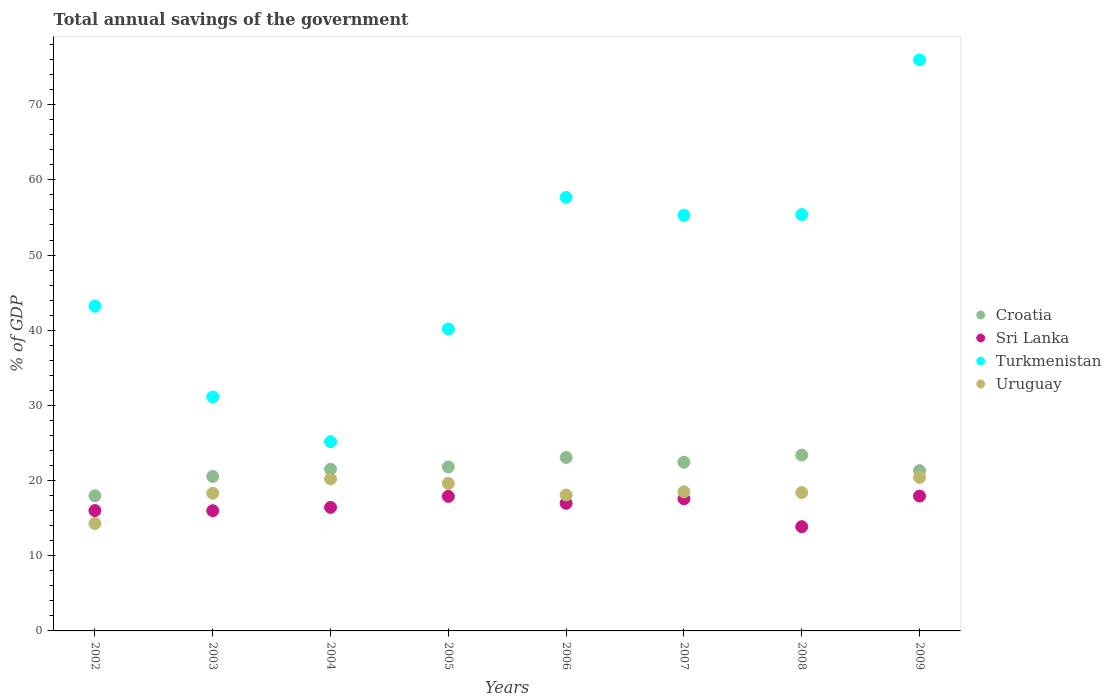How many different coloured dotlines are there?
Your answer should be compact. 4. Is the number of dotlines equal to the number of legend labels?
Offer a very short reply. Yes. What is the total annual savings of the government in Sri Lanka in 2002?
Make the answer very short. 16.01. Across all years, what is the maximum total annual savings of the government in Sri Lanka?
Provide a succinct answer. 17.94. Across all years, what is the minimum total annual savings of the government in Croatia?
Your response must be concise. 17.98. In which year was the total annual savings of the government in Uruguay maximum?
Provide a succinct answer. 2009. In which year was the total annual savings of the government in Turkmenistan minimum?
Offer a terse response. 2004. What is the total total annual savings of the government in Turkmenistan in the graph?
Provide a succinct answer. 383.96. What is the difference between the total annual savings of the government in Sri Lanka in 2005 and that in 2008?
Provide a short and direct response. 4.03. What is the difference between the total annual savings of the government in Turkmenistan in 2006 and the total annual savings of the government in Sri Lanka in 2003?
Make the answer very short. 41.68. What is the average total annual savings of the government in Croatia per year?
Give a very brief answer. 21.51. In the year 2008, what is the difference between the total annual savings of the government in Croatia and total annual savings of the government in Uruguay?
Keep it short and to the point. 4.99. What is the ratio of the total annual savings of the government in Uruguay in 2006 to that in 2009?
Ensure brevity in your answer.  0.89. Is the total annual savings of the government in Croatia in 2007 less than that in 2009?
Your answer should be very brief. No. What is the difference between the highest and the second highest total annual savings of the government in Croatia?
Offer a very short reply. 0.33. What is the difference between the highest and the lowest total annual savings of the government in Sri Lanka?
Provide a succinct answer. 4.08. Is it the case that in every year, the sum of the total annual savings of the government in Turkmenistan and total annual savings of the government in Croatia  is greater than the total annual savings of the government in Sri Lanka?
Offer a terse response. Yes. Does the total annual savings of the government in Turkmenistan monotonically increase over the years?
Give a very brief answer. No. Is the total annual savings of the government in Sri Lanka strictly greater than the total annual savings of the government in Uruguay over the years?
Offer a terse response. No. How many dotlines are there?
Provide a succinct answer. 4. How many years are there in the graph?
Give a very brief answer. 8. What is the difference between two consecutive major ticks on the Y-axis?
Make the answer very short. 10. How many legend labels are there?
Your answer should be very brief. 4. How are the legend labels stacked?
Offer a very short reply. Vertical. What is the title of the graph?
Provide a succinct answer. Total annual savings of the government. What is the label or title of the X-axis?
Make the answer very short. Years. What is the label or title of the Y-axis?
Provide a succinct answer. % of GDP. What is the % of GDP of Croatia in 2002?
Make the answer very short. 17.98. What is the % of GDP in Sri Lanka in 2002?
Offer a very short reply. 16.01. What is the % of GDP of Turkmenistan in 2002?
Your answer should be compact. 43.2. What is the % of GDP in Uruguay in 2002?
Your response must be concise. 14.29. What is the % of GDP of Croatia in 2003?
Provide a short and direct response. 20.55. What is the % of GDP in Sri Lanka in 2003?
Your answer should be compact. 15.99. What is the % of GDP in Turkmenistan in 2003?
Your answer should be compact. 31.12. What is the % of GDP in Uruguay in 2003?
Keep it short and to the point. 18.31. What is the % of GDP of Croatia in 2004?
Your answer should be compact. 21.52. What is the % of GDP of Sri Lanka in 2004?
Your answer should be very brief. 16.43. What is the % of GDP of Turkmenistan in 2004?
Offer a terse response. 25.17. What is the % of GDP of Uruguay in 2004?
Your answer should be very brief. 20.22. What is the % of GDP in Croatia in 2005?
Keep it short and to the point. 21.8. What is the % of GDP of Sri Lanka in 2005?
Your response must be concise. 17.9. What is the % of GDP of Turkmenistan in 2005?
Offer a very short reply. 40.17. What is the % of GDP of Uruguay in 2005?
Provide a short and direct response. 19.63. What is the % of GDP of Croatia in 2006?
Provide a short and direct response. 23.07. What is the % of GDP in Sri Lanka in 2006?
Provide a succinct answer. 16.98. What is the % of GDP of Turkmenistan in 2006?
Your answer should be compact. 57.67. What is the % of GDP in Uruguay in 2006?
Provide a short and direct response. 18.08. What is the % of GDP in Croatia in 2007?
Provide a succinct answer. 22.44. What is the % of GDP of Sri Lanka in 2007?
Give a very brief answer. 17.58. What is the % of GDP of Turkmenistan in 2007?
Give a very brief answer. 55.29. What is the % of GDP of Uruguay in 2007?
Make the answer very short. 18.5. What is the % of GDP in Croatia in 2008?
Your response must be concise. 23.39. What is the % of GDP in Sri Lanka in 2008?
Provide a short and direct response. 13.87. What is the % of GDP in Turkmenistan in 2008?
Provide a succinct answer. 55.38. What is the % of GDP in Uruguay in 2008?
Keep it short and to the point. 18.41. What is the % of GDP of Croatia in 2009?
Your answer should be very brief. 21.32. What is the % of GDP in Sri Lanka in 2009?
Your answer should be compact. 17.94. What is the % of GDP of Turkmenistan in 2009?
Your response must be concise. 75.96. What is the % of GDP of Uruguay in 2009?
Your response must be concise. 20.42. Across all years, what is the maximum % of GDP of Croatia?
Offer a terse response. 23.39. Across all years, what is the maximum % of GDP in Sri Lanka?
Your answer should be compact. 17.94. Across all years, what is the maximum % of GDP in Turkmenistan?
Keep it short and to the point. 75.96. Across all years, what is the maximum % of GDP of Uruguay?
Provide a succinct answer. 20.42. Across all years, what is the minimum % of GDP of Croatia?
Offer a terse response. 17.98. Across all years, what is the minimum % of GDP in Sri Lanka?
Offer a very short reply. 13.87. Across all years, what is the minimum % of GDP in Turkmenistan?
Your answer should be compact. 25.17. Across all years, what is the minimum % of GDP of Uruguay?
Your answer should be very brief. 14.29. What is the total % of GDP of Croatia in the graph?
Keep it short and to the point. 172.07. What is the total % of GDP of Sri Lanka in the graph?
Make the answer very short. 132.69. What is the total % of GDP of Turkmenistan in the graph?
Make the answer very short. 383.96. What is the total % of GDP in Uruguay in the graph?
Your response must be concise. 147.85. What is the difference between the % of GDP of Croatia in 2002 and that in 2003?
Offer a very short reply. -2.57. What is the difference between the % of GDP of Sri Lanka in 2002 and that in 2003?
Keep it short and to the point. 0.02. What is the difference between the % of GDP of Turkmenistan in 2002 and that in 2003?
Your response must be concise. 12.09. What is the difference between the % of GDP in Uruguay in 2002 and that in 2003?
Keep it short and to the point. -4.02. What is the difference between the % of GDP of Croatia in 2002 and that in 2004?
Your answer should be compact. -3.54. What is the difference between the % of GDP of Sri Lanka in 2002 and that in 2004?
Offer a terse response. -0.42. What is the difference between the % of GDP of Turkmenistan in 2002 and that in 2004?
Keep it short and to the point. 18.03. What is the difference between the % of GDP of Uruguay in 2002 and that in 2004?
Your answer should be very brief. -5.93. What is the difference between the % of GDP of Croatia in 2002 and that in 2005?
Provide a short and direct response. -3.82. What is the difference between the % of GDP in Sri Lanka in 2002 and that in 2005?
Give a very brief answer. -1.89. What is the difference between the % of GDP in Turkmenistan in 2002 and that in 2005?
Ensure brevity in your answer.  3.03. What is the difference between the % of GDP in Uruguay in 2002 and that in 2005?
Give a very brief answer. -5.34. What is the difference between the % of GDP in Croatia in 2002 and that in 2006?
Make the answer very short. -5.09. What is the difference between the % of GDP of Sri Lanka in 2002 and that in 2006?
Your answer should be very brief. -0.97. What is the difference between the % of GDP of Turkmenistan in 2002 and that in 2006?
Ensure brevity in your answer.  -14.47. What is the difference between the % of GDP of Uruguay in 2002 and that in 2006?
Keep it short and to the point. -3.8. What is the difference between the % of GDP in Croatia in 2002 and that in 2007?
Ensure brevity in your answer.  -4.46. What is the difference between the % of GDP in Sri Lanka in 2002 and that in 2007?
Give a very brief answer. -1.57. What is the difference between the % of GDP in Turkmenistan in 2002 and that in 2007?
Your answer should be compact. -12.09. What is the difference between the % of GDP of Uruguay in 2002 and that in 2007?
Your response must be concise. -4.21. What is the difference between the % of GDP of Croatia in 2002 and that in 2008?
Provide a short and direct response. -5.42. What is the difference between the % of GDP of Sri Lanka in 2002 and that in 2008?
Offer a terse response. 2.14. What is the difference between the % of GDP in Turkmenistan in 2002 and that in 2008?
Give a very brief answer. -12.18. What is the difference between the % of GDP in Uruguay in 2002 and that in 2008?
Provide a short and direct response. -4.12. What is the difference between the % of GDP in Croatia in 2002 and that in 2009?
Offer a terse response. -3.35. What is the difference between the % of GDP of Sri Lanka in 2002 and that in 2009?
Give a very brief answer. -1.93. What is the difference between the % of GDP in Turkmenistan in 2002 and that in 2009?
Provide a succinct answer. -32.75. What is the difference between the % of GDP in Uruguay in 2002 and that in 2009?
Give a very brief answer. -6.13. What is the difference between the % of GDP in Croatia in 2003 and that in 2004?
Provide a short and direct response. -0.97. What is the difference between the % of GDP of Sri Lanka in 2003 and that in 2004?
Provide a short and direct response. -0.44. What is the difference between the % of GDP of Turkmenistan in 2003 and that in 2004?
Make the answer very short. 5.94. What is the difference between the % of GDP of Uruguay in 2003 and that in 2004?
Offer a terse response. -1.9. What is the difference between the % of GDP in Croatia in 2003 and that in 2005?
Provide a succinct answer. -1.26. What is the difference between the % of GDP in Sri Lanka in 2003 and that in 2005?
Ensure brevity in your answer.  -1.91. What is the difference between the % of GDP of Turkmenistan in 2003 and that in 2005?
Offer a terse response. -9.05. What is the difference between the % of GDP of Uruguay in 2003 and that in 2005?
Your answer should be very brief. -1.32. What is the difference between the % of GDP in Croatia in 2003 and that in 2006?
Give a very brief answer. -2.52. What is the difference between the % of GDP in Sri Lanka in 2003 and that in 2006?
Ensure brevity in your answer.  -0.98. What is the difference between the % of GDP in Turkmenistan in 2003 and that in 2006?
Provide a short and direct response. -26.56. What is the difference between the % of GDP in Uruguay in 2003 and that in 2006?
Your answer should be very brief. 0.23. What is the difference between the % of GDP of Croatia in 2003 and that in 2007?
Give a very brief answer. -1.89. What is the difference between the % of GDP of Sri Lanka in 2003 and that in 2007?
Ensure brevity in your answer.  -1.58. What is the difference between the % of GDP of Turkmenistan in 2003 and that in 2007?
Ensure brevity in your answer.  -24.18. What is the difference between the % of GDP in Uruguay in 2003 and that in 2007?
Your answer should be very brief. -0.18. What is the difference between the % of GDP of Croatia in 2003 and that in 2008?
Your response must be concise. -2.85. What is the difference between the % of GDP in Sri Lanka in 2003 and that in 2008?
Your answer should be very brief. 2.12. What is the difference between the % of GDP of Turkmenistan in 2003 and that in 2008?
Provide a succinct answer. -24.27. What is the difference between the % of GDP of Uruguay in 2003 and that in 2008?
Offer a terse response. -0.09. What is the difference between the % of GDP in Croatia in 2003 and that in 2009?
Your answer should be very brief. -0.78. What is the difference between the % of GDP in Sri Lanka in 2003 and that in 2009?
Keep it short and to the point. -1.95. What is the difference between the % of GDP in Turkmenistan in 2003 and that in 2009?
Offer a terse response. -44.84. What is the difference between the % of GDP in Uruguay in 2003 and that in 2009?
Ensure brevity in your answer.  -2.11. What is the difference between the % of GDP of Croatia in 2004 and that in 2005?
Provide a short and direct response. -0.28. What is the difference between the % of GDP in Sri Lanka in 2004 and that in 2005?
Provide a succinct answer. -1.46. What is the difference between the % of GDP of Turkmenistan in 2004 and that in 2005?
Make the answer very short. -14.99. What is the difference between the % of GDP in Uruguay in 2004 and that in 2005?
Provide a succinct answer. 0.59. What is the difference between the % of GDP of Croatia in 2004 and that in 2006?
Offer a terse response. -1.55. What is the difference between the % of GDP of Sri Lanka in 2004 and that in 2006?
Ensure brevity in your answer.  -0.54. What is the difference between the % of GDP of Turkmenistan in 2004 and that in 2006?
Provide a short and direct response. -32.5. What is the difference between the % of GDP of Uruguay in 2004 and that in 2006?
Provide a succinct answer. 2.13. What is the difference between the % of GDP in Croatia in 2004 and that in 2007?
Ensure brevity in your answer.  -0.92. What is the difference between the % of GDP in Sri Lanka in 2004 and that in 2007?
Give a very brief answer. -1.14. What is the difference between the % of GDP in Turkmenistan in 2004 and that in 2007?
Your response must be concise. -30.12. What is the difference between the % of GDP of Uruguay in 2004 and that in 2007?
Keep it short and to the point. 1.72. What is the difference between the % of GDP of Croatia in 2004 and that in 2008?
Provide a succinct answer. -1.88. What is the difference between the % of GDP of Sri Lanka in 2004 and that in 2008?
Provide a short and direct response. 2.57. What is the difference between the % of GDP of Turkmenistan in 2004 and that in 2008?
Offer a terse response. -30.21. What is the difference between the % of GDP in Uruguay in 2004 and that in 2008?
Your answer should be very brief. 1.81. What is the difference between the % of GDP in Croatia in 2004 and that in 2009?
Ensure brevity in your answer.  0.19. What is the difference between the % of GDP of Sri Lanka in 2004 and that in 2009?
Your answer should be very brief. -1.51. What is the difference between the % of GDP in Turkmenistan in 2004 and that in 2009?
Your response must be concise. -50.78. What is the difference between the % of GDP of Uruguay in 2004 and that in 2009?
Your answer should be compact. -0.2. What is the difference between the % of GDP in Croatia in 2005 and that in 2006?
Offer a terse response. -1.27. What is the difference between the % of GDP of Sri Lanka in 2005 and that in 2006?
Your answer should be compact. 0.92. What is the difference between the % of GDP in Turkmenistan in 2005 and that in 2006?
Your answer should be compact. -17.5. What is the difference between the % of GDP of Uruguay in 2005 and that in 2006?
Your response must be concise. 1.55. What is the difference between the % of GDP in Croatia in 2005 and that in 2007?
Your response must be concise. -0.63. What is the difference between the % of GDP in Sri Lanka in 2005 and that in 2007?
Ensure brevity in your answer.  0.32. What is the difference between the % of GDP in Turkmenistan in 2005 and that in 2007?
Offer a very short reply. -15.13. What is the difference between the % of GDP in Uruguay in 2005 and that in 2007?
Your response must be concise. 1.13. What is the difference between the % of GDP of Croatia in 2005 and that in 2008?
Your answer should be compact. -1.59. What is the difference between the % of GDP in Sri Lanka in 2005 and that in 2008?
Keep it short and to the point. 4.03. What is the difference between the % of GDP of Turkmenistan in 2005 and that in 2008?
Keep it short and to the point. -15.21. What is the difference between the % of GDP of Uruguay in 2005 and that in 2008?
Provide a short and direct response. 1.22. What is the difference between the % of GDP in Croatia in 2005 and that in 2009?
Keep it short and to the point. 0.48. What is the difference between the % of GDP in Sri Lanka in 2005 and that in 2009?
Your answer should be very brief. -0.04. What is the difference between the % of GDP of Turkmenistan in 2005 and that in 2009?
Give a very brief answer. -35.79. What is the difference between the % of GDP in Uruguay in 2005 and that in 2009?
Provide a short and direct response. -0.79. What is the difference between the % of GDP in Croatia in 2006 and that in 2007?
Give a very brief answer. 0.63. What is the difference between the % of GDP of Sri Lanka in 2006 and that in 2007?
Give a very brief answer. -0.6. What is the difference between the % of GDP in Turkmenistan in 2006 and that in 2007?
Your answer should be compact. 2.38. What is the difference between the % of GDP in Uruguay in 2006 and that in 2007?
Keep it short and to the point. -0.41. What is the difference between the % of GDP in Croatia in 2006 and that in 2008?
Offer a terse response. -0.33. What is the difference between the % of GDP of Sri Lanka in 2006 and that in 2008?
Keep it short and to the point. 3.11. What is the difference between the % of GDP of Turkmenistan in 2006 and that in 2008?
Make the answer very short. 2.29. What is the difference between the % of GDP in Uruguay in 2006 and that in 2008?
Provide a succinct answer. -0.32. What is the difference between the % of GDP in Croatia in 2006 and that in 2009?
Your answer should be very brief. 1.74. What is the difference between the % of GDP in Sri Lanka in 2006 and that in 2009?
Offer a very short reply. -0.97. What is the difference between the % of GDP of Turkmenistan in 2006 and that in 2009?
Your answer should be very brief. -18.28. What is the difference between the % of GDP of Uruguay in 2006 and that in 2009?
Ensure brevity in your answer.  -2.33. What is the difference between the % of GDP of Croatia in 2007 and that in 2008?
Your answer should be very brief. -0.96. What is the difference between the % of GDP in Sri Lanka in 2007 and that in 2008?
Offer a very short reply. 3.71. What is the difference between the % of GDP of Turkmenistan in 2007 and that in 2008?
Your response must be concise. -0.09. What is the difference between the % of GDP in Uruguay in 2007 and that in 2008?
Offer a very short reply. 0.09. What is the difference between the % of GDP in Croatia in 2007 and that in 2009?
Offer a terse response. 1.11. What is the difference between the % of GDP of Sri Lanka in 2007 and that in 2009?
Offer a very short reply. -0.37. What is the difference between the % of GDP in Turkmenistan in 2007 and that in 2009?
Your answer should be compact. -20.66. What is the difference between the % of GDP of Uruguay in 2007 and that in 2009?
Give a very brief answer. -1.92. What is the difference between the % of GDP of Croatia in 2008 and that in 2009?
Provide a succinct answer. 2.07. What is the difference between the % of GDP in Sri Lanka in 2008 and that in 2009?
Provide a short and direct response. -4.08. What is the difference between the % of GDP of Turkmenistan in 2008 and that in 2009?
Give a very brief answer. -20.57. What is the difference between the % of GDP of Uruguay in 2008 and that in 2009?
Ensure brevity in your answer.  -2.01. What is the difference between the % of GDP of Croatia in 2002 and the % of GDP of Sri Lanka in 2003?
Ensure brevity in your answer.  1.99. What is the difference between the % of GDP of Croatia in 2002 and the % of GDP of Turkmenistan in 2003?
Provide a succinct answer. -13.14. What is the difference between the % of GDP in Croatia in 2002 and the % of GDP in Uruguay in 2003?
Keep it short and to the point. -0.33. What is the difference between the % of GDP in Sri Lanka in 2002 and the % of GDP in Turkmenistan in 2003?
Keep it short and to the point. -15.11. What is the difference between the % of GDP in Sri Lanka in 2002 and the % of GDP in Uruguay in 2003?
Your answer should be very brief. -2.3. What is the difference between the % of GDP in Turkmenistan in 2002 and the % of GDP in Uruguay in 2003?
Make the answer very short. 24.89. What is the difference between the % of GDP of Croatia in 2002 and the % of GDP of Sri Lanka in 2004?
Your answer should be compact. 1.54. What is the difference between the % of GDP in Croatia in 2002 and the % of GDP in Turkmenistan in 2004?
Give a very brief answer. -7.2. What is the difference between the % of GDP of Croatia in 2002 and the % of GDP of Uruguay in 2004?
Ensure brevity in your answer.  -2.24. What is the difference between the % of GDP in Sri Lanka in 2002 and the % of GDP in Turkmenistan in 2004?
Ensure brevity in your answer.  -9.16. What is the difference between the % of GDP of Sri Lanka in 2002 and the % of GDP of Uruguay in 2004?
Ensure brevity in your answer.  -4.21. What is the difference between the % of GDP of Turkmenistan in 2002 and the % of GDP of Uruguay in 2004?
Make the answer very short. 22.99. What is the difference between the % of GDP of Croatia in 2002 and the % of GDP of Sri Lanka in 2005?
Offer a very short reply. 0.08. What is the difference between the % of GDP of Croatia in 2002 and the % of GDP of Turkmenistan in 2005?
Offer a terse response. -22.19. What is the difference between the % of GDP in Croatia in 2002 and the % of GDP in Uruguay in 2005?
Ensure brevity in your answer.  -1.65. What is the difference between the % of GDP of Sri Lanka in 2002 and the % of GDP of Turkmenistan in 2005?
Provide a succinct answer. -24.16. What is the difference between the % of GDP in Sri Lanka in 2002 and the % of GDP in Uruguay in 2005?
Offer a terse response. -3.62. What is the difference between the % of GDP of Turkmenistan in 2002 and the % of GDP of Uruguay in 2005?
Offer a very short reply. 23.57. What is the difference between the % of GDP of Croatia in 2002 and the % of GDP of Turkmenistan in 2006?
Your response must be concise. -39.69. What is the difference between the % of GDP in Croatia in 2002 and the % of GDP in Uruguay in 2006?
Ensure brevity in your answer.  -0.11. What is the difference between the % of GDP of Sri Lanka in 2002 and the % of GDP of Turkmenistan in 2006?
Your answer should be compact. -41.66. What is the difference between the % of GDP of Sri Lanka in 2002 and the % of GDP of Uruguay in 2006?
Offer a very short reply. -2.07. What is the difference between the % of GDP in Turkmenistan in 2002 and the % of GDP in Uruguay in 2006?
Give a very brief answer. 25.12. What is the difference between the % of GDP of Croatia in 2002 and the % of GDP of Sri Lanka in 2007?
Offer a very short reply. 0.4. What is the difference between the % of GDP in Croatia in 2002 and the % of GDP in Turkmenistan in 2007?
Your answer should be compact. -37.32. What is the difference between the % of GDP of Croatia in 2002 and the % of GDP of Uruguay in 2007?
Provide a succinct answer. -0.52. What is the difference between the % of GDP in Sri Lanka in 2002 and the % of GDP in Turkmenistan in 2007?
Provide a short and direct response. -39.28. What is the difference between the % of GDP in Sri Lanka in 2002 and the % of GDP in Uruguay in 2007?
Provide a succinct answer. -2.49. What is the difference between the % of GDP of Turkmenistan in 2002 and the % of GDP of Uruguay in 2007?
Offer a very short reply. 24.71. What is the difference between the % of GDP of Croatia in 2002 and the % of GDP of Sri Lanka in 2008?
Give a very brief answer. 4.11. What is the difference between the % of GDP in Croatia in 2002 and the % of GDP in Turkmenistan in 2008?
Offer a very short reply. -37.41. What is the difference between the % of GDP of Croatia in 2002 and the % of GDP of Uruguay in 2008?
Provide a short and direct response. -0.43. What is the difference between the % of GDP in Sri Lanka in 2002 and the % of GDP in Turkmenistan in 2008?
Make the answer very short. -39.37. What is the difference between the % of GDP of Sri Lanka in 2002 and the % of GDP of Uruguay in 2008?
Your answer should be compact. -2.4. What is the difference between the % of GDP in Turkmenistan in 2002 and the % of GDP in Uruguay in 2008?
Offer a very short reply. 24.8. What is the difference between the % of GDP of Croatia in 2002 and the % of GDP of Sri Lanka in 2009?
Offer a very short reply. 0.04. What is the difference between the % of GDP of Croatia in 2002 and the % of GDP of Turkmenistan in 2009?
Give a very brief answer. -57.98. What is the difference between the % of GDP in Croatia in 2002 and the % of GDP in Uruguay in 2009?
Provide a succinct answer. -2.44. What is the difference between the % of GDP of Sri Lanka in 2002 and the % of GDP of Turkmenistan in 2009?
Keep it short and to the point. -59.95. What is the difference between the % of GDP of Sri Lanka in 2002 and the % of GDP of Uruguay in 2009?
Keep it short and to the point. -4.41. What is the difference between the % of GDP in Turkmenistan in 2002 and the % of GDP in Uruguay in 2009?
Offer a very short reply. 22.79. What is the difference between the % of GDP in Croatia in 2003 and the % of GDP in Sri Lanka in 2004?
Provide a succinct answer. 4.11. What is the difference between the % of GDP in Croatia in 2003 and the % of GDP in Turkmenistan in 2004?
Provide a short and direct response. -4.63. What is the difference between the % of GDP in Croatia in 2003 and the % of GDP in Uruguay in 2004?
Offer a terse response. 0.33. What is the difference between the % of GDP of Sri Lanka in 2003 and the % of GDP of Turkmenistan in 2004?
Offer a terse response. -9.18. What is the difference between the % of GDP in Sri Lanka in 2003 and the % of GDP in Uruguay in 2004?
Your response must be concise. -4.23. What is the difference between the % of GDP in Turkmenistan in 2003 and the % of GDP in Uruguay in 2004?
Provide a succinct answer. 10.9. What is the difference between the % of GDP of Croatia in 2003 and the % of GDP of Sri Lanka in 2005?
Provide a succinct answer. 2.65. What is the difference between the % of GDP in Croatia in 2003 and the % of GDP in Turkmenistan in 2005?
Provide a succinct answer. -19.62. What is the difference between the % of GDP of Croatia in 2003 and the % of GDP of Uruguay in 2005?
Ensure brevity in your answer.  0.92. What is the difference between the % of GDP of Sri Lanka in 2003 and the % of GDP of Turkmenistan in 2005?
Ensure brevity in your answer.  -24.18. What is the difference between the % of GDP in Sri Lanka in 2003 and the % of GDP in Uruguay in 2005?
Keep it short and to the point. -3.64. What is the difference between the % of GDP of Turkmenistan in 2003 and the % of GDP of Uruguay in 2005?
Make the answer very short. 11.49. What is the difference between the % of GDP in Croatia in 2003 and the % of GDP in Sri Lanka in 2006?
Ensure brevity in your answer.  3.57. What is the difference between the % of GDP of Croatia in 2003 and the % of GDP of Turkmenistan in 2006?
Your response must be concise. -37.12. What is the difference between the % of GDP in Croatia in 2003 and the % of GDP in Uruguay in 2006?
Give a very brief answer. 2.46. What is the difference between the % of GDP in Sri Lanka in 2003 and the % of GDP in Turkmenistan in 2006?
Ensure brevity in your answer.  -41.68. What is the difference between the % of GDP of Sri Lanka in 2003 and the % of GDP of Uruguay in 2006?
Your response must be concise. -2.09. What is the difference between the % of GDP of Turkmenistan in 2003 and the % of GDP of Uruguay in 2006?
Provide a short and direct response. 13.03. What is the difference between the % of GDP of Croatia in 2003 and the % of GDP of Sri Lanka in 2007?
Your response must be concise. 2.97. What is the difference between the % of GDP of Croatia in 2003 and the % of GDP of Turkmenistan in 2007?
Ensure brevity in your answer.  -34.75. What is the difference between the % of GDP of Croatia in 2003 and the % of GDP of Uruguay in 2007?
Provide a succinct answer. 2.05. What is the difference between the % of GDP of Sri Lanka in 2003 and the % of GDP of Turkmenistan in 2007?
Give a very brief answer. -39.3. What is the difference between the % of GDP of Sri Lanka in 2003 and the % of GDP of Uruguay in 2007?
Your response must be concise. -2.51. What is the difference between the % of GDP in Turkmenistan in 2003 and the % of GDP in Uruguay in 2007?
Provide a succinct answer. 12.62. What is the difference between the % of GDP in Croatia in 2003 and the % of GDP in Sri Lanka in 2008?
Provide a succinct answer. 6.68. What is the difference between the % of GDP in Croatia in 2003 and the % of GDP in Turkmenistan in 2008?
Keep it short and to the point. -34.84. What is the difference between the % of GDP of Croatia in 2003 and the % of GDP of Uruguay in 2008?
Your answer should be compact. 2.14. What is the difference between the % of GDP of Sri Lanka in 2003 and the % of GDP of Turkmenistan in 2008?
Make the answer very short. -39.39. What is the difference between the % of GDP of Sri Lanka in 2003 and the % of GDP of Uruguay in 2008?
Your answer should be compact. -2.41. What is the difference between the % of GDP in Turkmenistan in 2003 and the % of GDP in Uruguay in 2008?
Give a very brief answer. 12.71. What is the difference between the % of GDP in Croatia in 2003 and the % of GDP in Sri Lanka in 2009?
Provide a short and direct response. 2.6. What is the difference between the % of GDP of Croatia in 2003 and the % of GDP of Turkmenistan in 2009?
Offer a terse response. -55.41. What is the difference between the % of GDP in Croatia in 2003 and the % of GDP in Uruguay in 2009?
Offer a terse response. 0.13. What is the difference between the % of GDP in Sri Lanka in 2003 and the % of GDP in Turkmenistan in 2009?
Your response must be concise. -59.96. What is the difference between the % of GDP in Sri Lanka in 2003 and the % of GDP in Uruguay in 2009?
Your answer should be very brief. -4.43. What is the difference between the % of GDP of Turkmenistan in 2003 and the % of GDP of Uruguay in 2009?
Your answer should be compact. 10.7. What is the difference between the % of GDP in Croatia in 2004 and the % of GDP in Sri Lanka in 2005?
Your response must be concise. 3.62. What is the difference between the % of GDP in Croatia in 2004 and the % of GDP in Turkmenistan in 2005?
Offer a terse response. -18.65. What is the difference between the % of GDP in Croatia in 2004 and the % of GDP in Uruguay in 2005?
Make the answer very short. 1.89. What is the difference between the % of GDP in Sri Lanka in 2004 and the % of GDP in Turkmenistan in 2005?
Ensure brevity in your answer.  -23.74. What is the difference between the % of GDP of Sri Lanka in 2004 and the % of GDP of Uruguay in 2005?
Give a very brief answer. -3.2. What is the difference between the % of GDP of Turkmenistan in 2004 and the % of GDP of Uruguay in 2005?
Ensure brevity in your answer.  5.54. What is the difference between the % of GDP of Croatia in 2004 and the % of GDP of Sri Lanka in 2006?
Provide a succinct answer. 4.54. What is the difference between the % of GDP in Croatia in 2004 and the % of GDP in Turkmenistan in 2006?
Make the answer very short. -36.15. What is the difference between the % of GDP in Croatia in 2004 and the % of GDP in Uruguay in 2006?
Make the answer very short. 3.43. What is the difference between the % of GDP in Sri Lanka in 2004 and the % of GDP in Turkmenistan in 2006?
Give a very brief answer. -41.24. What is the difference between the % of GDP of Sri Lanka in 2004 and the % of GDP of Uruguay in 2006?
Offer a terse response. -1.65. What is the difference between the % of GDP in Turkmenistan in 2004 and the % of GDP in Uruguay in 2006?
Offer a terse response. 7.09. What is the difference between the % of GDP of Croatia in 2004 and the % of GDP of Sri Lanka in 2007?
Give a very brief answer. 3.94. What is the difference between the % of GDP in Croatia in 2004 and the % of GDP in Turkmenistan in 2007?
Provide a succinct answer. -33.78. What is the difference between the % of GDP of Croatia in 2004 and the % of GDP of Uruguay in 2007?
Your answer should be compact. 3.02. What is the difference between the % of GDP in Sri Lanka in 2004 and the % of GDP in Turkmenistan in 2007?
Your answer should be compact. -38.86. What is the difference between the % of GDP of Sri Lanka in 2004 and the % of GDP of Uruguay in 2007?
Provide a succinct answer. -2.06. What is the difference between the % of GDP of Turkmenistan in 2004 and the % of GDP of Uruguay in 2007?
Give a very brief answer. 6.68. What is the difference between the % of GDP in Croatia in 2004 and the % of GDP in Sri Lanka in 2008?
Offer a very short reply. 7.65. What is the difference between the % of GDP in Croatia in 2004 and the % of GDP in Turkmenistan in 2008?
Your response must be concise. -33.86. What is the difference between the % of GDP in Croatia in 2004 and the % of GDP in Uruguay in 2008?
Your answer should be compact. 3.11. What is the difference between the % of GDP in Sri Lanka in 2004 and the % of GDP in Turkmenistan in 2008?
Provide a short and direct response. -38.95. What is the difference between the % of GDP in Sri Lanka in 2004 and the % of GDP in Uruguay in 2008?
Your answer should be compact. -1.97. What is the difference between the % of GDP of Turkmenistan in 2004 and the % of GDP of Uruguay in 2008?
Keep it short and to the point. 6.77. What is the difference between the % of GDP in Croatia in 2004 and the % of GDP in Sri Lanka in 2009?
Your response must be concise. 3.58. What is the difference between the % of GDP of Croatia in 2004 and the % of GDP of Turkmenistan in 2009?
Provide a short and direct response. -54.44. What is the difference between the % of GDP in Croatia in 2004 and the % of GDP in Uruguay in 2009?
Offer a very short reply. 1.1. What is the difference between the % of GDP in Sri Lanka in 2004 and the % of GDP in Turkmenistan in 2009?
Provide a short and direct response. -59.52. What is the difference between the % of GDP of Sri Lanka in 2004 and the % of GDP of Uruguay in 2009?
Provide a succinct answer. -3.98. What is the difference between the % of GDP of Turkmenistan in 2004 and the % of GDP of Uruguay in 2009?
Offer a very short reply. 4.76. What is the difference between the % of GDP of Croatia in 2005 and the % of GDP of Sri Lanka in 2006?
Offer a very short reply. 4.83. What is the difference between the % of GDP of Croatia in 2005 and the % of GDP of Turkmenistan in 2006?
Your response must be concise. -35.87. What is the difference between the % of GDP in Croatia in 2005 and the % of GDP in Uruguay in 2006?
Keep it short and to the point. 3.72. What is the difference between the % of GDP of Sri Lanka in 2005 and the % of GDP of Turkmenistan in 2006?
Give a very brief answer. -39.77. What is the difference between the % of GDP of Sri Lanka in 2005 and the % of GDP of Uruguay in 2006?
Provide a short and direct response. -0.19. What is the difference between the % of GDP of Turkmenistan in 2005 and the % of GDP of Uruguay in 2006?
Your answer should be very brief. 22.08. What is the difference between the % of GDP of Croatia in 2005 and the % of GDP of Sri Lanka in 2007?
Offer a terse response. 4.23. What is the difference between the % of GDP of Croatia in 2005 and the % of GDP of Turkmenistan in 2007?
Provide a short and direct response. -33.49. What is the difference between the % of GDP in Croatia in 2005 and the % of GDP in Uruguay in 2007?
Make the answer very short. 3.31. What is the difference between the % of GDP of Sri Lanka in 2005 and the % of GDP of Turkmenistan in 2007?
Your answer should be compact. -37.4. What is the difference between the % of GDP in Sri Lanka in 2005 and the % of GDP in Uruguay in 2007?
Ensure brevity in your answer.  -0.6. What is the difference between the % of GDP in Turkmenistan in 2005 and the % of GDP in Uruguay in 2007?
Make the answer very short. 21.67. What is the difference between the % of GDP of Croatia in 2005 and the % of GDP of Sri Lanka in 2008?
Keep it short and to the point. 7.94. What is the difference between the % of GDP in Croatia in 2005 and the % of GDP in Turkmenistan in 2008?
Offer a terse response. -33.58. What is the difference between the % of GDP of Croatia in 2005 and the % of GDP of Uruguay in 2008?
Make the answer very short. 3.4. What is the difference between the % of GDP in Sri Lanka in 2005 and the % of GDP in Turkmenistan in 2008?
Your response must be concise. -37.49. What is the difference between the % of GDP of Sri Lanka in 2005 and the % of GDP of Uruguay in 2008?
Keep it short and to the point. -0.51. What is the difference between the % of GDP in Turkmenistan in 2005 and the % of GDP in Uruguay in 2008?
Offer a terse response. 21.76. What is the difference between the % of GDP in Croatia in 2005 and the % of GDP in Sri Lanka in 2009?
Your answer should be compact. 3.86. What is the difference between the % of GDP in Croatia in 2005 and the % of GDP in Turkmenistan in 2009?
Your answer should be very brief. -54.15. What is the difference between the % of GDP in Croatia in 2005 and the % of GDP in Uruguay in 2009?
Ensure brevity in your answer.  1.38. What is the difference between the % of GDP in Sri Lanka in 2005 and the % of GDP in Turkmenistan in 2009?
Your answer should be very brief. -58.06. What is the difference between the % of GDP of Sri Lanka in 2005 and the % of GDP of Uruguay in 2009?
Your response must be concise. -2.52. What is the difference between the % of GDP of Turkmenistan in 2005 and the % of GDP of Uruguay in 2009?
Make the answer very short. 19.75. What is the difference between the % of GDP of Croatia in 2006 and the % of GDP of Sri Lanka in 2007?
Provide a short and direct response. 5.49. What is the difference between the % of GDP of Croatia in 2006 and the % of GDP of Turkmenistan in 2007?
Give a very brief answer. -32.23. What is the difference between the % of GDP of Croatia in 2006 and the % of GDP of Uruguay in 2007?
Offer a very short reply. 4.57. What is the difference between the % of GDP of Sri Lanka in 2006 and the % of GDP of Turkmenistan in 2007?
Keep it short and to the point. -38.32. What is the difference between the % of GDP of Sri Lanka in 2006 and the % of GDP of Uruguay in 2007?
Offer a very short reply. -1.52. What is the difference between the % of GDP of Turkmenistan in 2006 and the % of GDP of Uruguay in 2007?
Your answer should be compact. 39.17. What is the difference between the % of GDP in Croatia in 2006 and the % of GDP in Sri Lanka in 2008?
Offer a terse response. 9.2. What is the difference between the % of GDP in Croatia in 2006 and the % of GDP in Turkmenistan in 2008?
Provide a short and direct response. -32.31. What is the difference between the % of GDP in Croatia in 2006 and the % of GDP in Uruguay in 2008?
Keep it short and to the point. 4.66. What is the difference between the % of GDP in Sri Lanka in 2006 and the % of GDP in Turkmenistan in 2008?
Provide a succinct answer. -38.41. What is the difference between the % of GDP in Sri Lanka in 2006 and the % of GDP in Uruguay in 2008?
Your answer should be compact. -1.43. What is the difference between the % of GDP in Turkmenistan in 2006 and the % of GDP in Uruguay in 2008?
Your answer should be very brief. 39.26. What is the difference between the % of GDP in Croatia in 2006 and the % of GDP in Sri Lanka in 2009?
Offer a very short reply. 5.13. What is the difference between the % of GDP in Croatia in 2006 and the % of GDP in Turkmenistan in 2009?
Ensure brevity in your answer.  -52.89. What is the difference between the % of GDP in Croatia in 2006 and the % of GDP in Uruguay in 2009?
Your answer should be compact. 2.65. What is the difference between the % of GDP of Sri Lanka in 2006 and the % of GDP of Turkmenistan in 2009?
Make the answer very short. -58.98. What is the difference between the % of GDP of Sri Lanka in 2006 and the % of GDP of Uruguay in 2009?
Your response must be concise. -3.44. What is the difference between the % of GDP of Turkmenistan in 2006 and the % of GDP of Uruguay in 2009?
Offer a terse response. 37.25. What is the difference between the % of GDP of Croatia in 2007 and the % of GDP of Sri Lanka in 2008?
Your answer should be very brief. 8.57. What is the difference between the % of GDP in Croatia in 2007 and the % of GDP in Turkmenistan in 2008?
Your response must be concise. -32.95. What is the difference between the % of GDP of Croatia in 2007 and the % of GDP of Uruguay in 2008?
Make the answer very short. 4.03. What is the difference between the % of GDP of Sri Lanka in 2007 and the % of GDP of Turkmenistan in 2008?
Your answer should be compact. -37.81. What is the difference between the % of GDP of Sri Lanka in 2007 and the % of GDP of Uruguay in 2008?
Your answer should be compact. -0.83. What is the difference between the % of GDP in Turkmenistan in 2007 and the % of GDP in Uruguay in 2008?
Make the answer very short. 36.89. What is the difference between the % of GDP of Croatia in 2007 and the % of GDP of Sri Lanka in 2009?
Make the answer very short. 4.49. What is the difference between the % of GDP of Croatia in 2007 and the % of GDP of Turkmenistan in 2009?
Provide a succinct answer. -53.52. What is the difference between the % of GDP in Croatia in 2007 and the % of GDP in Uruguay in 2009?
Your response must be concise. 2.02. What is the difference between the % of GDP in Sri Lanka in 2007 and the % of GDP in Turkmenistan in 2009?
Give a very brief answer. -58.38. What is the difference between the % of GDP of Sri Lanka in 2007 and the % of GDP of Uruguay in 2009?
Keep it short and to the point. -2.84. What is the difference between the % of GDP in Turkmenistan in 2007 and the % of GDP in Uruguay in 2009?
Ensure brevity in your answer.  34.88. What is the difference between the % of GDP of Croatia in 2008 and the % of GDP of Sri Lanka in 2009?
Keep it short and to the point. 5.45. What is the difference between the % of GDP of Croatia in 2008 and the % of GDP of Turkmenistan in 2009?
Your response must be concise. -52.56. What is the difference between the % of GDP in Croatia in 2008 and the % of GDP in Uruguay in 2009?
Your answer should be very brief. 2.98. What is the difference between the % of GDP of Sri Lanka in 2008 and the % of GDP of Turkmenistan in 2009?
Provide a succinct answer. -62.09. What is the difference between the % of GDP in Sri Lanka in 2008 and the % of GDP in Uruguay in 2009?
Provide a short and direct response. -6.55. What is the difference between the % of GDP of Turkmenistan in 2008 and the % of GDP of Uruguay in 2009?
Give a very brief answer. 34.97. What is the average % of GDP in Croatia per year?
Provide a short and direct response. 21.51. What is the average % of GDP in Sri Lanka per year?
Offer a terse response. 16.59. What is the average % of GDP in Turkmenistan per year?
Offer a terse response. 48. What is the average % of GDP in Uruguay per year?
Provide a short and direct response. 18.48. In the year 2002, what is the difference between the % of GDP of Croatia and % of GDP of Sri Lanka?
Your answer should be compact. 1.97. In the year 2002, what is the difference between the % of GDP in Croatia and % of GDP in Turkmenistan?
Your response must be concise. -25.23. In the year 2002, what is the difference between the % of GDP of Croatia and % of GDP of Uruguay?
Provide a short and direct response. 3.69. In the year 2002, what is the difference between the % of GDP of Sri Lanka and % of GDP of Turkmenistan?
Provide a succinct answer. -27.19. In the year 2002, what is the difference between the % of GDP of Sri Lanka and % of GDP of Uruguay?
Offer a very short reply. 1.72. In the year 2002, what is the difference between the % of GDP of Turkmenistan and % of GDP of Uruguay?
Offer a very short reply. 28.92. In the year 2003, what is the difference between the % of GDP of Croatia and % of GDP of Sri Lanka?
Keep it short and to the point. 4.56. In the year 2003, what is the difference between the % of GDP of Croatia and % of GDP of Turkmenistan?
Provide a succinct answer. -10.57. In the year 2003, what is the difference between the % of GDP in Croatia and % of GDP in Uruguay?
Offer a terse response. 2.23. In the year 2003, what is the difference between the % of GDP of Sri Lanka and % of GDP of Turkmenistan?
Offer a very short reply. -15.12. In the year 2003, what is the difference between the % of GDP of Sri Lanka and % of GDP of Uruguay?
Offer a very short reply. -2.32. In the year 2003, what is the difference between the % of GDP of Turkmenistan and % of GDP of Uruguay?
Offer a very short reply. 12.8. In the year 2004, what is the difference between the % of GDP in Croatia and % of GDP in Sri Lanka?
Keep it short and to the point. 5.09. In the year 2004, what is the difference between the % of GDP of Croatia and % of GDP of Turkmenistan?
Keep it short and to the point. -3.66. In the year 2004, what is the difference between the % of GDP in Croatia and % of GDP in Uruguay?
Offer a very short reply. 1.3. In the year 2004, what is the difference between the % of GDP of Sri Lanka and % of GDP of Turkmenistan?
Offer a very short reply. -8.74. In the year 2004, what is the difference between the % of GDP of Sri Lanka and % of GDP of Uruguay?
Your answer should be compact. -3.78. In the year 2004, what is the difference between the % of GDP of Turkmenistan and % of GDP of Uruguay?
Your response must be concise. 4.96. In the year 2005, what is the difference between the % of GDP in Croatia and % of GDP in Sri Lanka?
Your response must be concise. 3.9. In the year 2005, what is the difference between the % of GDP of Croatia and % of GDP of Turkmenistan?
Offer a terse response. -18.37. In the year 2005, what is the difference between the % of GDP of Croatia and % of GDP of Uruguay?
Keep it short and to the point. 2.17. In the year 2005, what is the difference between the % of GDP of Sri Lanka and % of GDP of Turkmenistan?
Your answer should be very brief. -22.27. In the year 2005, what is the difference between the % of GDP in Sri Lanka and % of GDP in Uruguay?
Your answer should be very brief. -1.73. In the year 2005, what is the difference between the % of GDP in Turkmenistan and % of GDP in Uruguay?
Your answer should be compact. 20.54. In the year 2006, what is the difference between the % of GDP of Croatia and % of GDP of Sri Lanka?
Offer a very short reply. 6.09. In the year 2006, what is the difference between the % of GDP of Croatia and % of GDP of Turkmenistan?
Provide a short and direct response. -34.6. In the year 2006, what is the difference between the % of GDP in Croatia and % of GDP in Uruguay?
Provide a succinct answer. 4.98. In the year 2006, what is the difference between the % of GDP of Sri Lanka and % of GDP of Turkmenistan?
Offer a very short reply. -40.69. In the year 2006, what is the difference between the % of GDP of Sri Lanka and % of GDP of Uruguay?
Your answer should be compact. -1.11. In the year 2006, what is the difference between the % of GDP of Turkmenistan and % of GDP of Uruguay?
Your answer should be compact. 39.59. In the year 2007, what is the difference between the % of GDP of Croatia and % of GDP of Sri Lanka?
Ensure brevity in your answer.  4.86. In the year 2007, what is the difference between the % of GDP in Croatia and % of GDP in Turkmenistan?
Make the answer very short. -32.86. In the year 2007, what is the difference between the % of GDP of Croatia and % of GDP of Uruguay?
Make the answer very short. 3.94. In the year 2007, what is the difference between the % of GDP in Sri Lanka and % of GDP in Turkmenistan?
Your answer should be very brief. -37.72. In the year 2007, what is the difference between the % of GDP in Sri Lanka and % of GDP in Uruguay?
Provide a succinct answer. -0.92. In the year 2007, what is the difference between the % of GDP in Turkmenistan and % of GDP in Uruguay?
Ensure brevity in your answer.  36.8. In the year 2008, what is the difference between the % of GDP in Croatia and % of GDP in Sri Lanka?
Provide a short and direct response. 9.53. In the year 2008, what is the difference between the % of GDP in Croatia and % of GDP in Turkmenistan?
Offer a terse response. -31.99. In the year 2008, what is the difference between the % of GDP in Croatia and % of GDP in Uruguay?
Provide a short and direct response. 4.99. In the year 2008, what is the difference between the % of GDP in Sri Lanka and % of GDP in Turkmenistan?
Offer a very short reply. -41.52. In the year 2008, what is the difference between the % of GDP in Sri Lanka and % of GDP in Uruguay?
Offer a very short reply. -4.54. In the year 2008, what is the difference between the % of GDP of Turkmenistan and % of GDP of Uruguay?
Provide a succinct answer. 36.98. In the year 2009, what is the difference between the % of GDP of Croatia and % of GDP of Sri Lanka?
Your answer should be very brief. 3.38. In the year 2009, what is the difference between the % of GDP in Croatia and % of GDP in Turkmenistan?
Make the answer very short. -54.63. In the year 2009, what is the difference between the % of GDP in Croatia and % of GDP in Uruguay?
Ensure brevity in your answer.  0.91. In the year 2009, what is the difference between the % of GDP of Sri Lanka and % of GDP of Turkmenistan?
Keep it short and to the point. -58.01. In the year 2009, what is the difference between the % of GDP of Sri Lanka and % of GDP of Uruguay?
Your answer should be compact. -2.48. In the year 2009, what is the difference between the % of GDP of Turkmenistan and % of GDP of Uruguay?
Ensure brevity in your answer.  55.54. What is the ratio of the % of GDP in Turkmenistan in 2002 to that in 2003?
Your answer should be compact. 1.39. What is the ratio of the % of GDP in Uruguay in 2002 to that in 2003?
Offer a very short reply. 0.78. What is the ratio of the % of GDP in Croatia in 2002 to that in 2004?
Provide a succinct answer. 0.84. What is the ratio of the % of GDP of Sri Lanka in 2002 to that in 2004?
Your answer should be compact. 0.97. What is the ratio of the % of GDP of Turkmenistan in 2002 to that in 2004?
Provide a short and direct response. 1.72. What is the ratio of the % of GDP in Uruguay in 2002 to that in 2004?
Keep it short and to the point. 0.71. What is the ratio of the % of GDP in Croatia in 2002 to that in 2005?
Offer a very short reply. 0.82. What is the ratio of the % of GDP in Sri Lanka in 2002 to that in 2005?
Keep it short and to the point. 0.89. What is the ratio of the % of GDP of Turkmenistan in 2002 to that in 2005?
Offer a very short reply. 1.08. What is the ratio of the % of GDP of Uruguay in 2002 to that in 2005?
Ensure brevity in your answer.  0.73. What is the ratio of the % of GDP in Croatia in 2002 to that in 2006?
Your response must be concise. 0.78. What is the ratio of the % of GDP in Sri Lanka in 2002 to that in 2006?
Your answer should be very brief. 0.94. What is the ratio of the % of GDP in Turkmenistan in 2002 to that in 2006?
Provide a short and direct response. 0.75. What is the ratio of the % of GDP of Uruguay in 2002 to that in 2006?
Provide a succinct answer. 0.79. What is the ratio of the % of GDP of Croatia in 2002 to that in 2007?
Keep it short and to the point. 0.8. What is the ratio of the % of GDP of Sri Lanka in 2002 to that in 2007?
Provide a short and direct response. 0.91. What is the ratio of the % of GDP of Turkmenistan in 2002 to that in 2007?
Provide a short and direct response. 0.78. What is the ratio of the % of GDP in Uruguay in 2002 to that in 2007?
Provide a short and direct response. 0.77. What is the ratio of the % of GDP in Croatia in 2002 to that in 2008?
Your answer should be very brief. 0.77. What is the ratio of the % of GDP in Sri Lanka in 2002 to that in 2008?
Give a very brief answer. 1.15. What is the ratio of the % of GDP of Turkmenistan in 2002 to that in 2008?
Give a very brief answer. 0.78. What is the ratio of the % of GDP in Uruguay in 2002 to that in 2008?
Provide a succinct answer. 0.78. What is the ratio of the % of GDP of Croatia in 2002 to that in 2009?
Ensure brevity in your answer.  0.84. What is the ratio of the % of GDP of Sri Lanka in 2002 to that in 2009?
Offer a very short reply. 0.89. What is the ratio of the % of GDP in Turkmenistan in 2002 to that in 2009?
Provide a succinct answer. 0.57. What is the ratio of the % of GDP in Uruguay in 2002 to that in 2009?
Keep it short and to the point. 0.7. What is the ratio of the % of GDP in Croatia in 2003 to that in 2004?
Ensure brevity in your answer.  0.95. What is the ratio of the % of GDP in Sri Lanka in 2003 to that in 2004?
Provide a short and direct response. 0.97. What is the ratio of the % of GDP in Turkmenistan in 2003 to that in 2004?
Make the answer very short. 1.24. What is the ratio of the % of GDP in Uruguay in 2003 to that in 2004?
Keep it short and to the point. 0.91. What is the ratio of the % of GDP of Croatia in 2003 to that in 2005?
Provide a short and direct response. 0.94. What is the ratio of the % of GDP of Sri Lanka in 2003 to that in 2005?
Your response must be concise. 0.89. What is the ratio of the % of GDP in Turkmenistan in 2003 to that in 2005?
Your answer should be compact. 0.77. What is the ratio of the % of GDP in Uruguay in 2003 to that in 2005?
Offer a terse response. 0.93. What is the ratio of the % of GDP in Croatia in 2003 to that in 2006?
Provide a succinct answer. 0.89. What is the ratio of the % of GDP of Sri Lanka in 2003 to that in 2006?
Ensure brevity in your answer.  0.94. What is the ratio of the % of GDP in Turkmenistan in 2003 to that in 2006?
Provide a short and direct response. 0.54. What is the ratio of the % of GDP in Uruguay in 2003 to that in 2006?
Give a very brief answer. 1.01. What is the ratio of the % of GDP of Croatia in 2003 to that in 2007?
Provide a succinct answer. 0.92. What is the ratio of the % of GDP in Sri Lanka in 2003 to that in 2007?
Provide a short and direct response. 0.91. What is the ratio of the % of GDP in Turkmenistan in 2003 to that in 2007?
Make the answer very short. 0.56. What is the ratio of the % of GDP of Uruguay in 2003 to that in 2007?
Offer a terse response. 0.99. What is the ratio of the % of GDP of Croatia in 2003 to that in 2008?
Make the answer very short. 0.88. What is the ratio of the % of GDP in Sri Lanka in 2003 to that in 2008?
Your answer should be compact. 1.15. What is the ratio of the % of GDP in Turkmenistan in 2003 to that in 2008?
Your answer should be compact. 0.56. What is the ratio of the % of GDP of Croatia in 2003 to that in 2009?
Your answer should be compact. 0.96. What is the ratio of the % of GDP in Sri Lanka in 2003 to that in 2009?
Your answer should be compact. 0.89. What is the ratio of the % of GDP in Turkmenistan in 2003 to that in 2009?
Offer a very short reply. 0.41. What is the ratio of the % of GDP of Uruguay in 2003 to that in 2009?
Provide a short and direct response. 0.9. What is the ratio of the % of GDP in Sri Lanka in 2004 to that in 2005?
Give a very brief answer. 0.92. What is the ratio of the % of GDP of Turkmenistan in 2004 to that in 2005?
Keep it short and to the point. 0.63. What is the ratio of the % of GDP in Uruguay in 2004 to that in 2005?
Offer a terse response. 1.03. What is the ratio of the % of GDP in Croatia in 2004 to that in 2006?
Offer a very short reply. 0.93. What is the ratio of the % of GDP of Turkmenistan in 2004 to that in 2006?
Your answer should be very brief. 0.44. What is the ratio of the % of GDP of Uruguay in 2004 to that in 2006?
Keep it short and to the point. 1.12. What is the ratio of the % of GDP of Croatia in 2004 to that in 2007?
Give a very brief answer. 0.96. What is the ratio of the % of GDP of Sri Lanka in 2004 to that in 2007?
Keep it short and to the point. 0.94. What is the ratio of the % of GDP in Turkmenistan in 2004 to that in 2007?
Your answer should be very brief. 0.46. What is the ratio of the % of GDP of Uruguay in 2004 to that in 2007?
Keep it short and to the point. 1.09. What is the ratio of the % of GDP of Croatia in 2004 to that in 2008?
Offer a very short reply. 0.92. What is the ratio of the % of GDP of Sri Lanka in 2004 to that in 2008?
Ensure brevity in your answer.  1.19. What is the ratio of the % of GDP in Turkmenistan in 2004 to that in 2008?
Provide a succinct answer. 0.45. What is the ratio of the % of GDP of Uruguay in 2004 to that in 2008?
Give a very brief answer. 1.1. What is the ratio of the % of GDP of Croatia in 2004 to that in 2009?
Provide a short and direct response. 1.01. What is the ratio of the % of GDP in Sri Lanka in 2004 to that in 2009?
Provide a succinct answer. 0.92. What is the ratio of the % of GDP in Turkmenistan in 2004 to that in 2009?
Keep it short and to the point. 0.33. What is the ratio of the % of GDP in Croatia in 2005 to that in 2006?
Give a very brief answer. 0.95. What is the ratio of the % of GDP of Sri Lanka in 2005 to that in 2006?
Make the answer very short. 1.05. What is the ratio of the % of GDP of Turkmenistan in 2005 to that in 2006?
Keep it short and to the point. 0.7. What is the ratio of the % of GDP in Uruguay in 2005 to that in 2006?
Your answer should be compact. 1.09. What is the ratio of the % of GDP in Croatia in 2005 to that in 2007?
Your response must be concise. 0.97. What is the ratio of the % of GDP of Sri Lanka in 2005 to that in 2007?
Your answer should be compact. 1.02. What is the ratio of the % of GDP of Turkmenistan in 2005 to that in 2007?
Ensure brevity in your answer.  0.73. What is the ratio of the % of GDP of Uruguay in 2005 to that in 2007?
Your response must be concise. 1.06. What is the ratio of the % of GDP in Croatia in 2005 to that in 2008?
Ensure brevity in your answer.  0.93. What is the ratio of the % of GDP of Sri Lanka in 2005 to that in 2008?
Your response must be concise. 1.29. What is the ratio of the % of GDP of Turkmenistan in 2005 to that in 2008?
Provide a short and direct response. 0.73. What is the ratio of the % of GDP of Uruguay in 2005 to that in 2008?
Your answer should be compact. 1.07. What is the ratio of the % of GDP of Croatia in 2005 to that in 2009?
Give a very brief answer. 1.02. What is the ratio of the % of GDP of Turkmenistan in 2005 to that in 2009?
Provide a succinct answer. 0.53. What is the ratio of the % of GDP of Uruguay in 2005 to that in 2009?
Give a very brief answer. 0.96. What is the ratio of the % of GDP of Croatia in 2006 to that in 2007?
Your response must be concise. 1.03. What is the ratio of the % of GDP in Sri Lanka in 2006 to that in 2007?
Offer a terse response. 0.97. What is the ratio of the % of GDP in Turkmenistan in 2006 to that in 2007?
Keep it short and to the point. 1.04. What is the ratio of the % of GDP in Uruguay in 2006 to that in 2007?
Ensure brevity in your answer.  0.98. What is the ratio of the % of GDP in Croatia in 2006 to that in 2008?
Offer a terse response. 0.99. What is the ratio of the % of GDP of Sri Lanka in 2006 to that in 2008?
Your answer should be compact. 1.22. What is the ratio of the % of GDP in Turkmenistan in 2006 to that in 2008?
Ensure brevity in your answer.  1.04. What is the ratio of the % of GDP in Uruguay in 2006 to that in 2008?
Give a very brief answer. 0.98. What is the ratio of the % of GDP in Croatia in 2006 to that in 2009?
Offer a terse response. 1.08. What is the ratio of the % of GDP in Sri Lanka in 2006 to that in 2009?
Ensure brevity in your answer.  0.95. What is the ratio of the % of GDP of Turkmenistan in 2006 to that in 2009?
Provide a succinct answer. 0.76. What is the ratio of the % of GDP of Uruguay in 2006 to that in 2009?
Offer a terse response. 0.89. What is the ratio of the % of GDP of Sri Lanka in 2007 to that in 2008?
Make the answer very short. 1.27. What is the ratio of the % of GDP in Turkmenistan in 2007 to that in 2008?
Give a very brief answer. 1. What is the ratio of the % of GDP in Uruguay in 2007 to that in 2008?
Keep it short and to the point. 1. What is the ratio of the % of GDP of Croatia in 2007 to that in 2009?
Your response must be concise. 1.05. What is the ratio of the % of GDP in Sri Lanka in 2007 to that in 2009?
Keep it short and to the point. 0.98. What is the ratio of the % of GDP in Turkmenistan in 2007 to that in 2009?
Provide a short and direct response. 0.73. What is the ratio of the % of GDP in Uruguay in 2007 to that in 2009?
Your response must be concise. 0.91. What is the ratio of the % of GDP of Croatia in 2008 to that in 2009?
Provide a succinct answer. 1.1. What is the ratio of the % of GDP of Sri Lanka in 2008 to that in 2009?
Offer a very short reply. 0.77. What is the ratio of the % of GDP in Turkmenistan in 2008 to that in 2009?
Your answer should be very brief. 0.73. What is the ratio of the % of GDP in Uruguay in 2008 to that in 2009?
Keep it short and to the point. 0.9. What is the difference between the highest and the second highest % of GDP of Croatia?
Keep it short and to the point. 0.33. What is the difference between the highest and the second highest % of GDP of Sri Lanka?
Make the answer very short. 0.04. What is the difference between the highest and the second highest % of GDP of Turkmenistan?
Give a very brief answer. 18.28. What is the difference between the highest and the second highest % of GDP of Uruguay?
Keep it short and to the point. 0.2. What is the difference between the highest and the lowest % of GDP in Croatia?
Ensure brevity in your answer.  5.42. What is the difference between the highest and the lowest % of GDP in Sri Lanka?
Offer a very short reply. 4.08. What is the difference between the highest and the lowest % of GDP of Turkmenistan?
Ensure brevity in your answer.  50.78. What is the difference between the highest and the lowest % of GDP in Uruguay?
Make the answer very short. 6.13. 